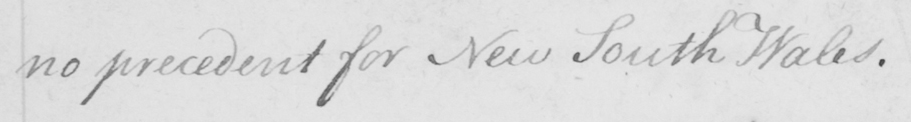Transcribe the text shown in this historical manuscript line. no precedent for New South Wales . 